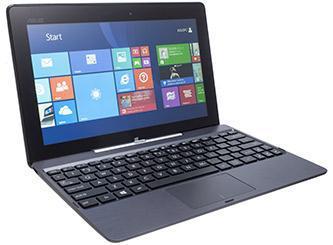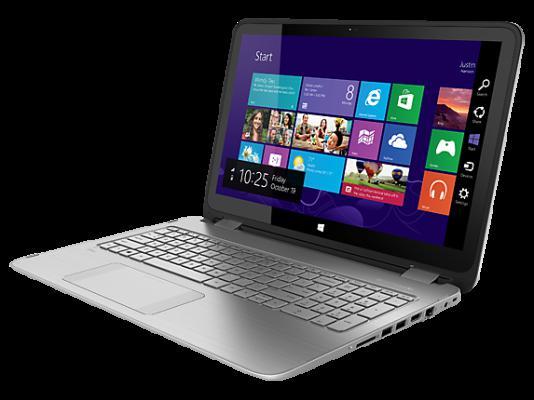The first image is the image on the left, the second image is the image on the right. Given the left and right images, does the statement "The laptops face the same direction." hold true? Answer yes or no. No. 